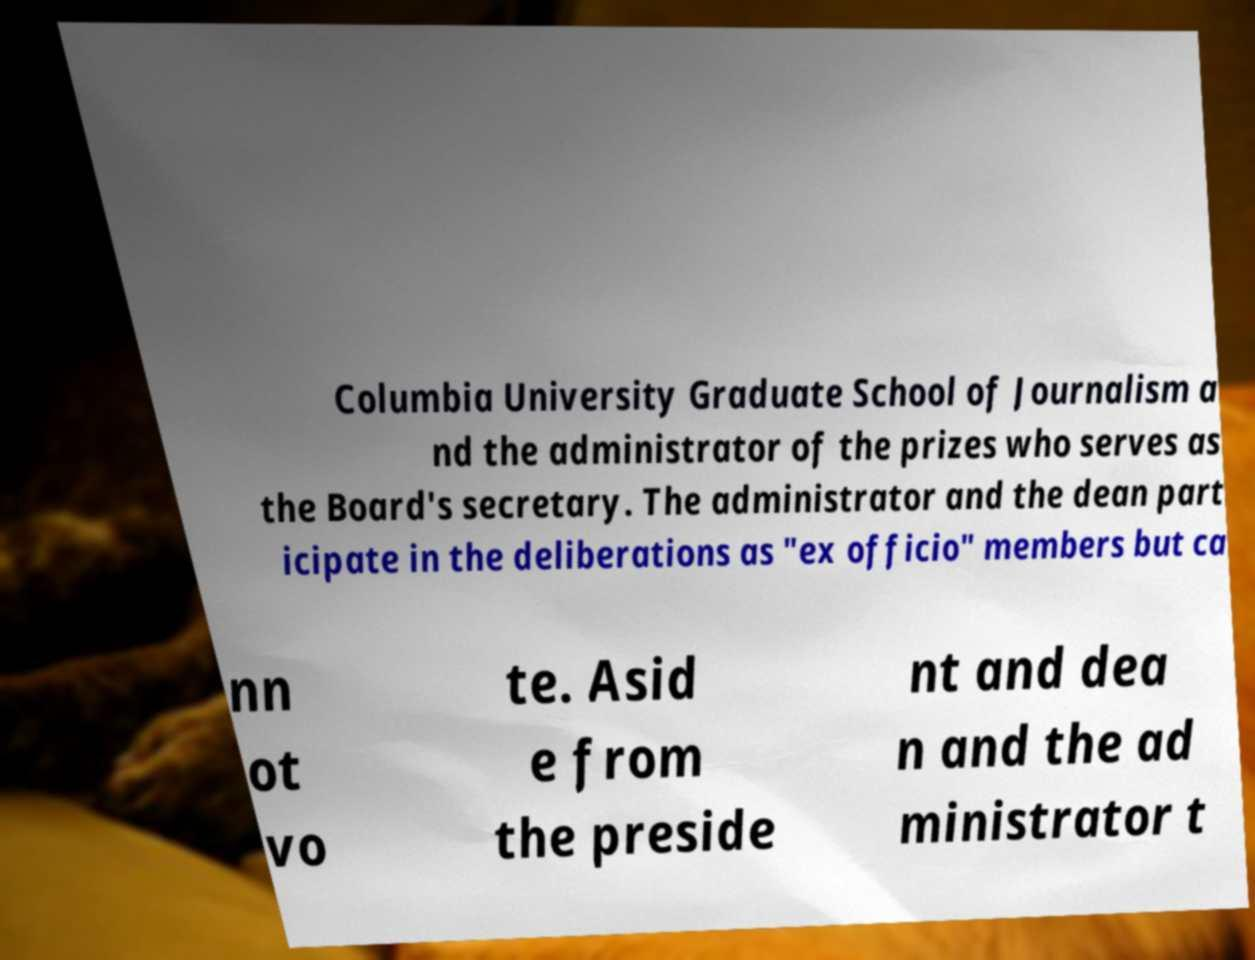Could you extract and type out the text from this image? Columbia University Graduate School of Journalism a nd the administrator of the prizes who serves as the Board's secretary. The administrator and the dean part icipate in the deliberations as "ex officio" members but ca nn ot vo te. Asid e from the preside nt and dea n and the ad ministrator t 